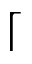<formula> <loc_0><loc_0><loc_500><loc_500>\lceil</formula> 